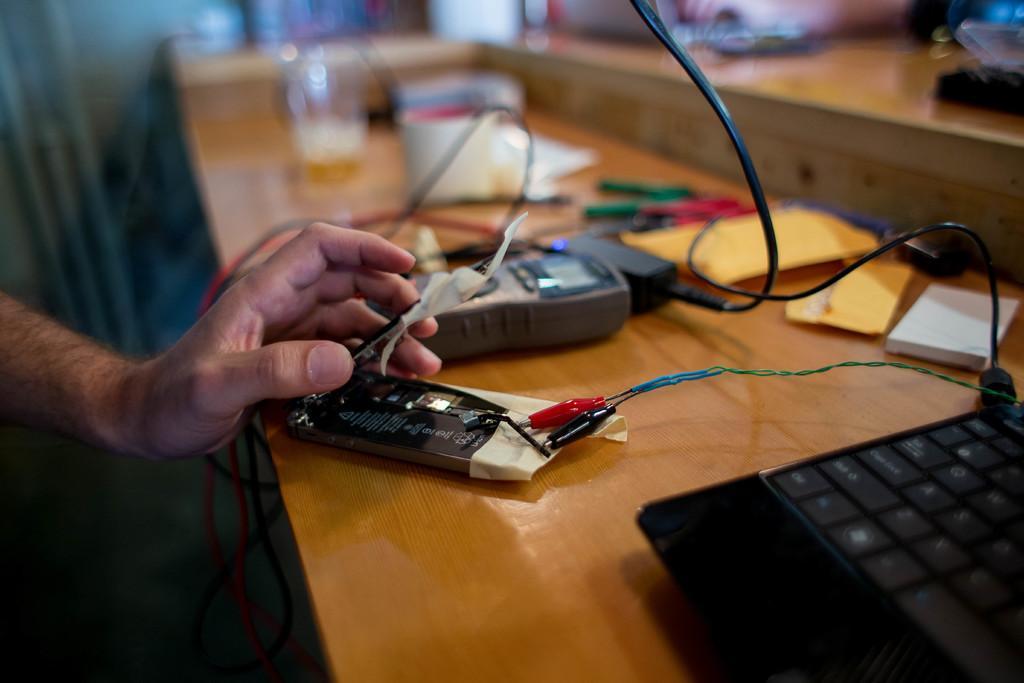Can you describe this image briefly? In this image, we can see a table, there is a laptop on the table, we can see the hand of a person and there are some objects kept on the table. 